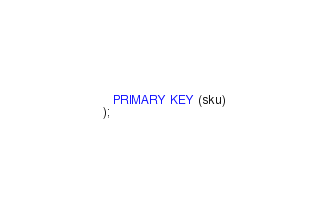Convert code to text. <code><loc_0><loc_0><loc_500><loc_500><_SQL_>     PRIMARY KEY (sku)
  );</code> 